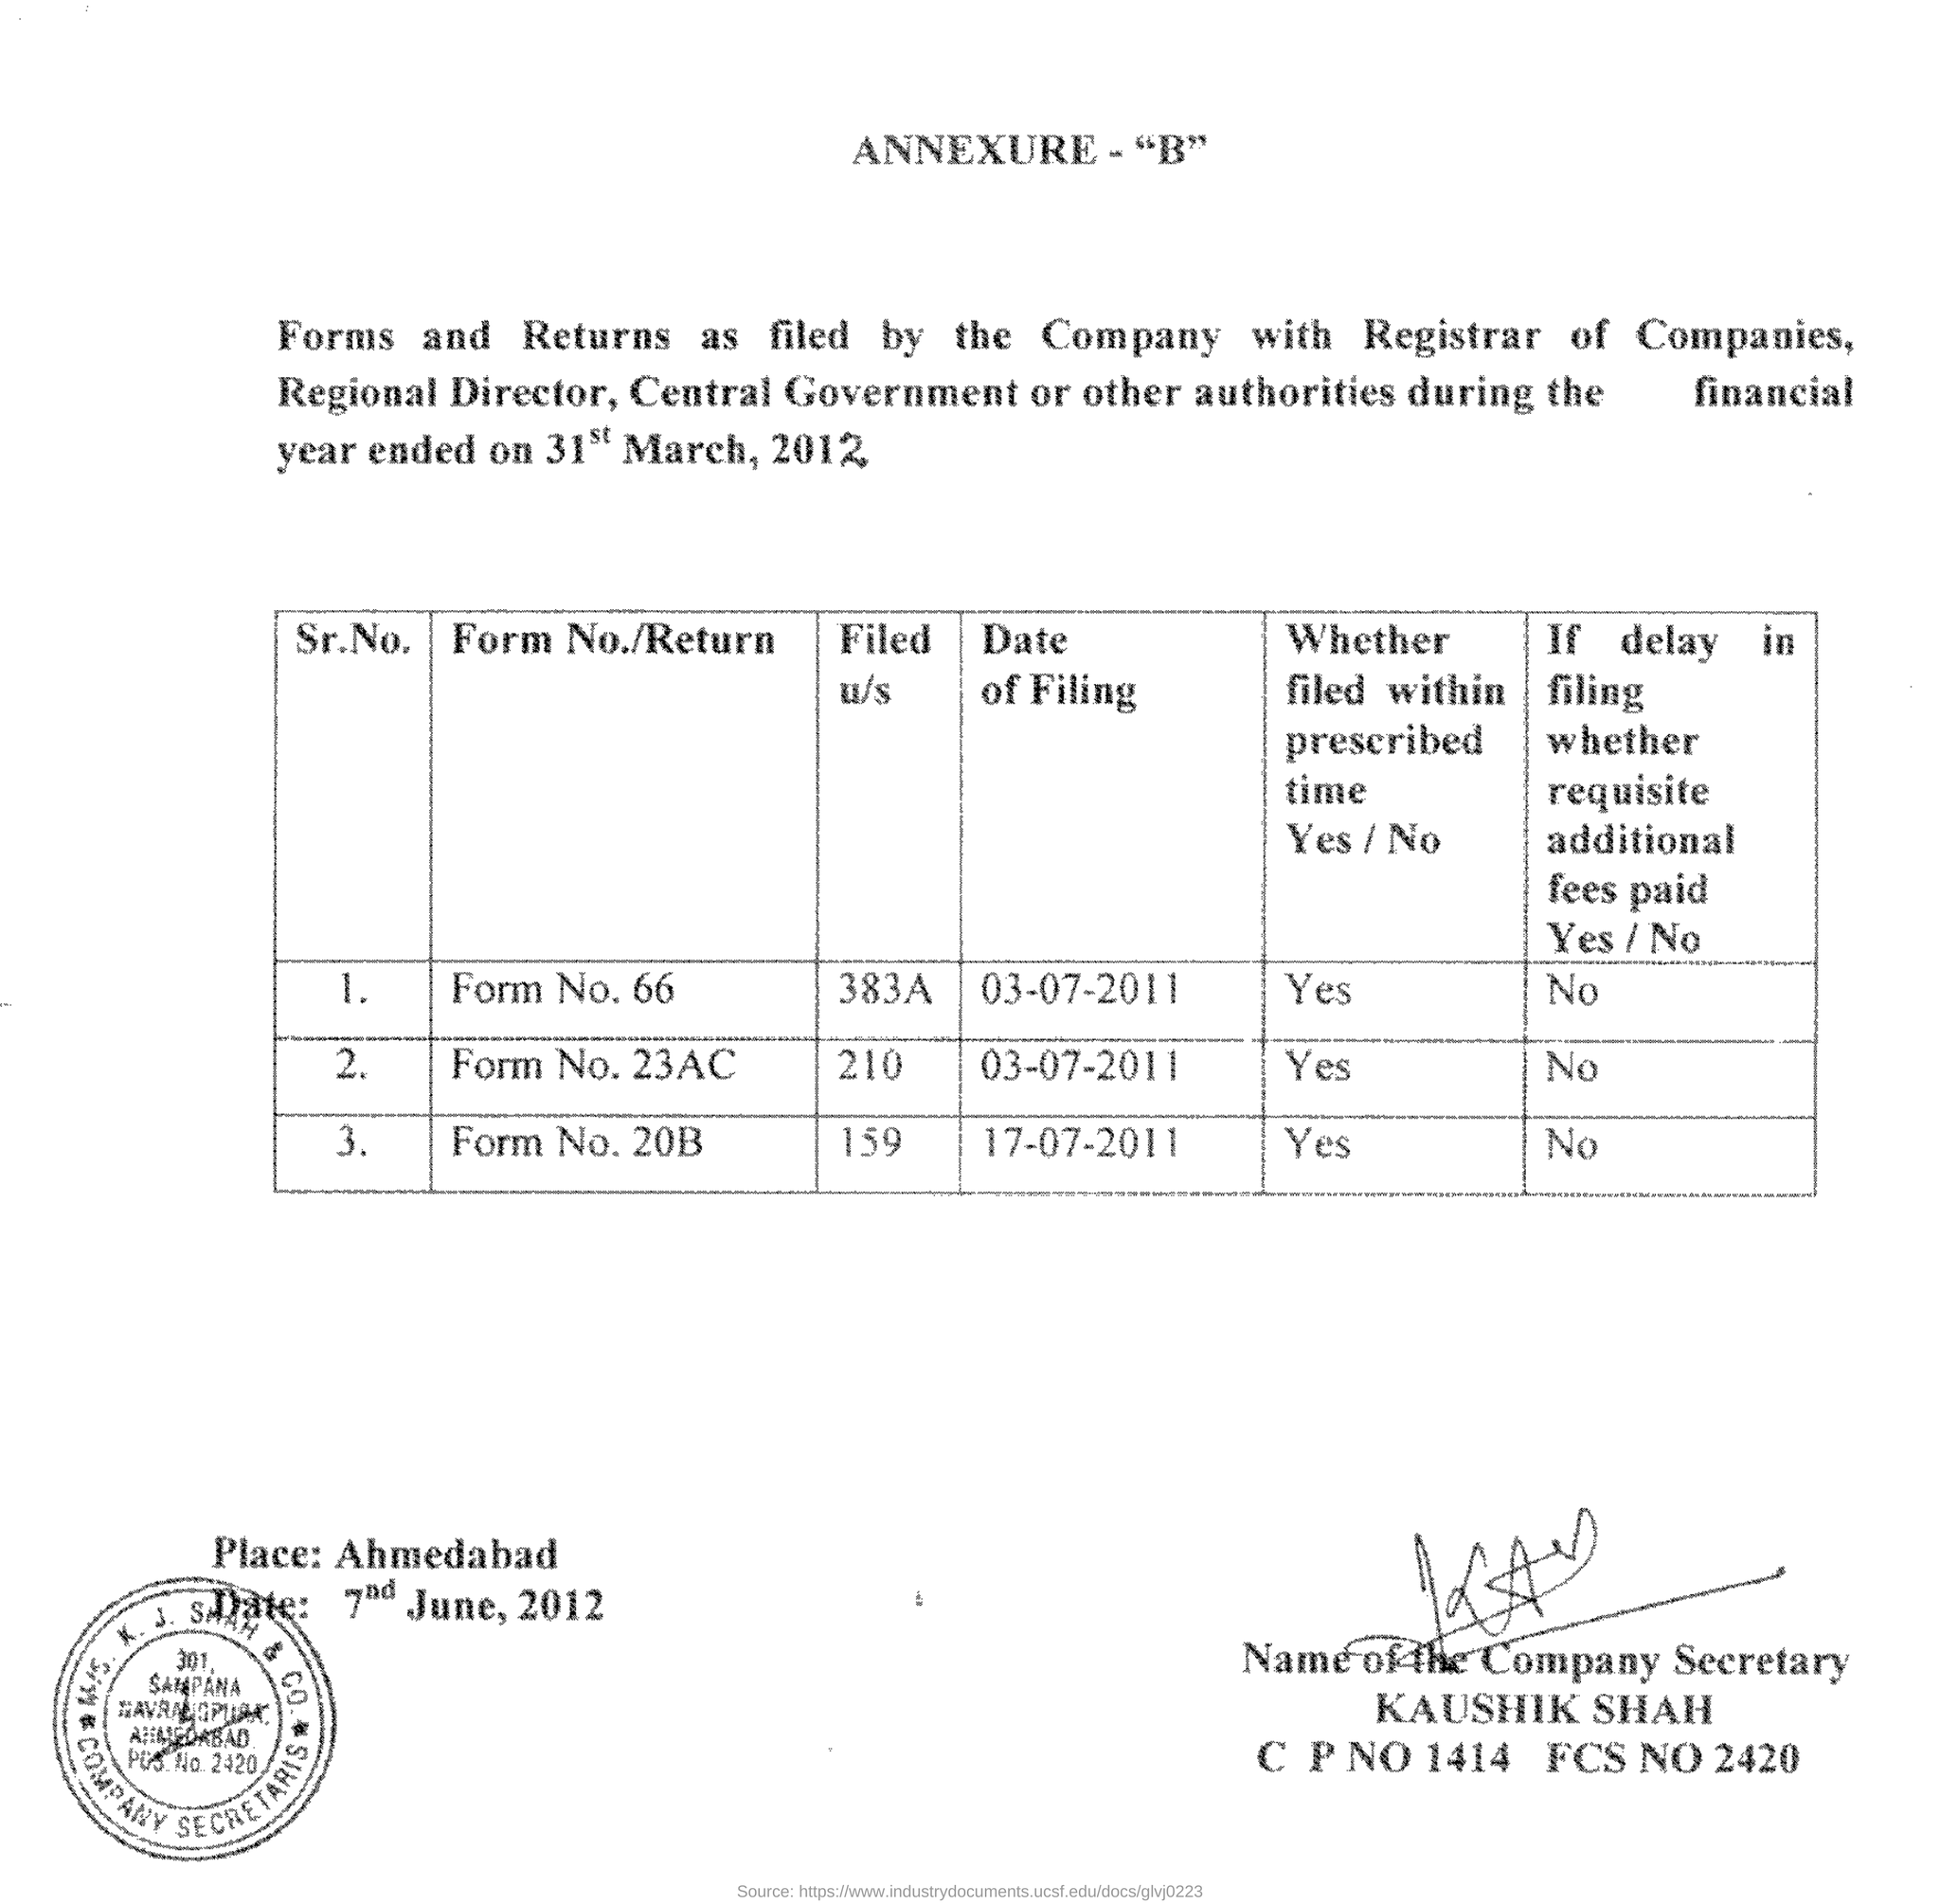Specify some key components in this picture. The form no.20B was filed within the prescribed time. The name of the company secretary is Kaushik Shah. The date of filing of Form No. 66 is July 3, 2011. 